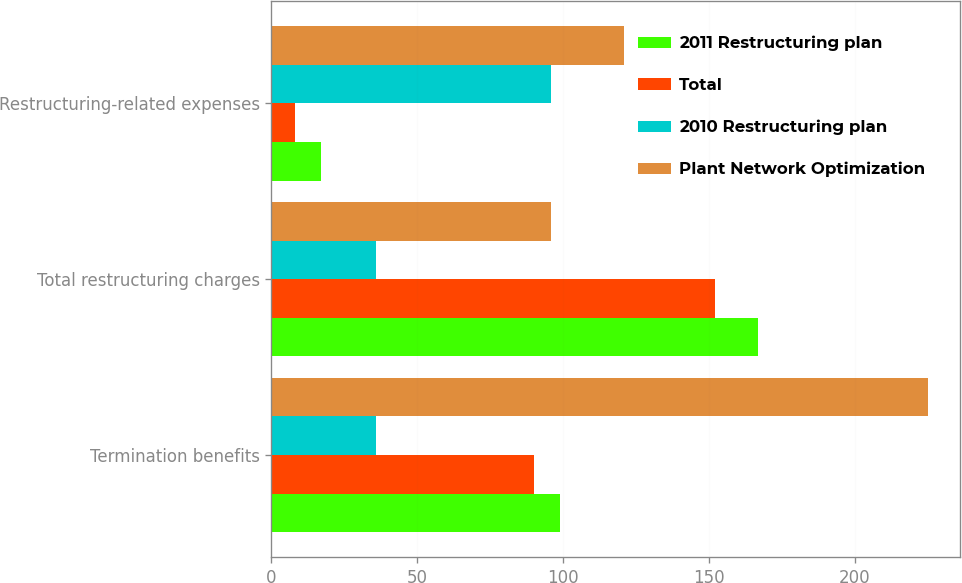Convert chart to OTSL. <chart><loc_0><loc_0><loc_500><loc_500><stacked_bar_chart><ecel><fcel>Termination benefits<fcel>Total restructuring charges<fcel>Restructuring-related expenses<nl><fcel>2011 Restructuring plan<fcel>99<fcel>167<fcel>17<nl><fcel>Total<fcel>90<fcel>152<fcel>8<nl><fcel>2010 Restructuring plan<fcel>36<fcel>36<fcel>96<nl><fcel>Plant Network Optimization<fcel>225<fcel>96<fcel>121<nl></chart> 